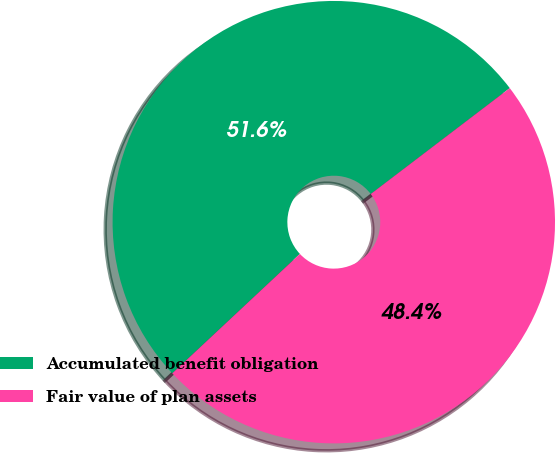Convert chart. <chart><loc_0><loc_0><loc_500><loc_500><pie_chart><fcel>Accumulated benefit obligation<fcel>Fair value of plan assets<nl><fcel>51.61%<fcel>48.39%<nl></chart> 